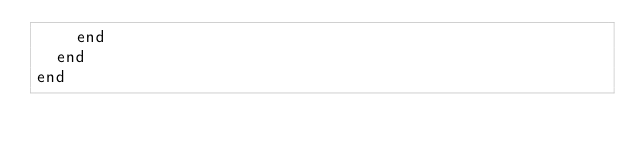<code> <loc_0><loc_0><loc_500><loc_500><_Ruby_>    end
  end
end
</code> 